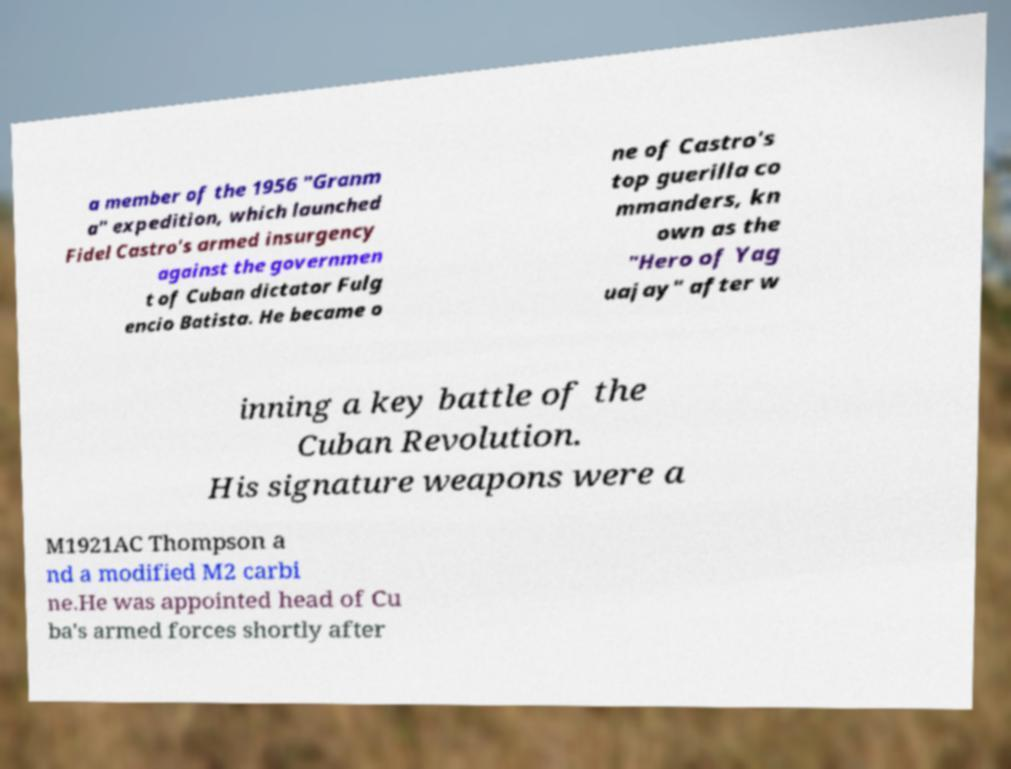I need the written content from this picture converted into text. Can you do that? a member of the 1956 "Granm a" expedition, which launched Fidel Castro's armed insurgency against the governmen t of Cuban dictator Fulg encio Batista. He became o ne of Castro's top guerilla co mmanders, kn own as the "Hero of Yag uajay" after w inning a key battle of the Cuban Revolution. His signature weapons were a M1921AC Thompson a nd a modified M2 carbi ne.He was appointed head of Cu ba's armed forces shortly after 